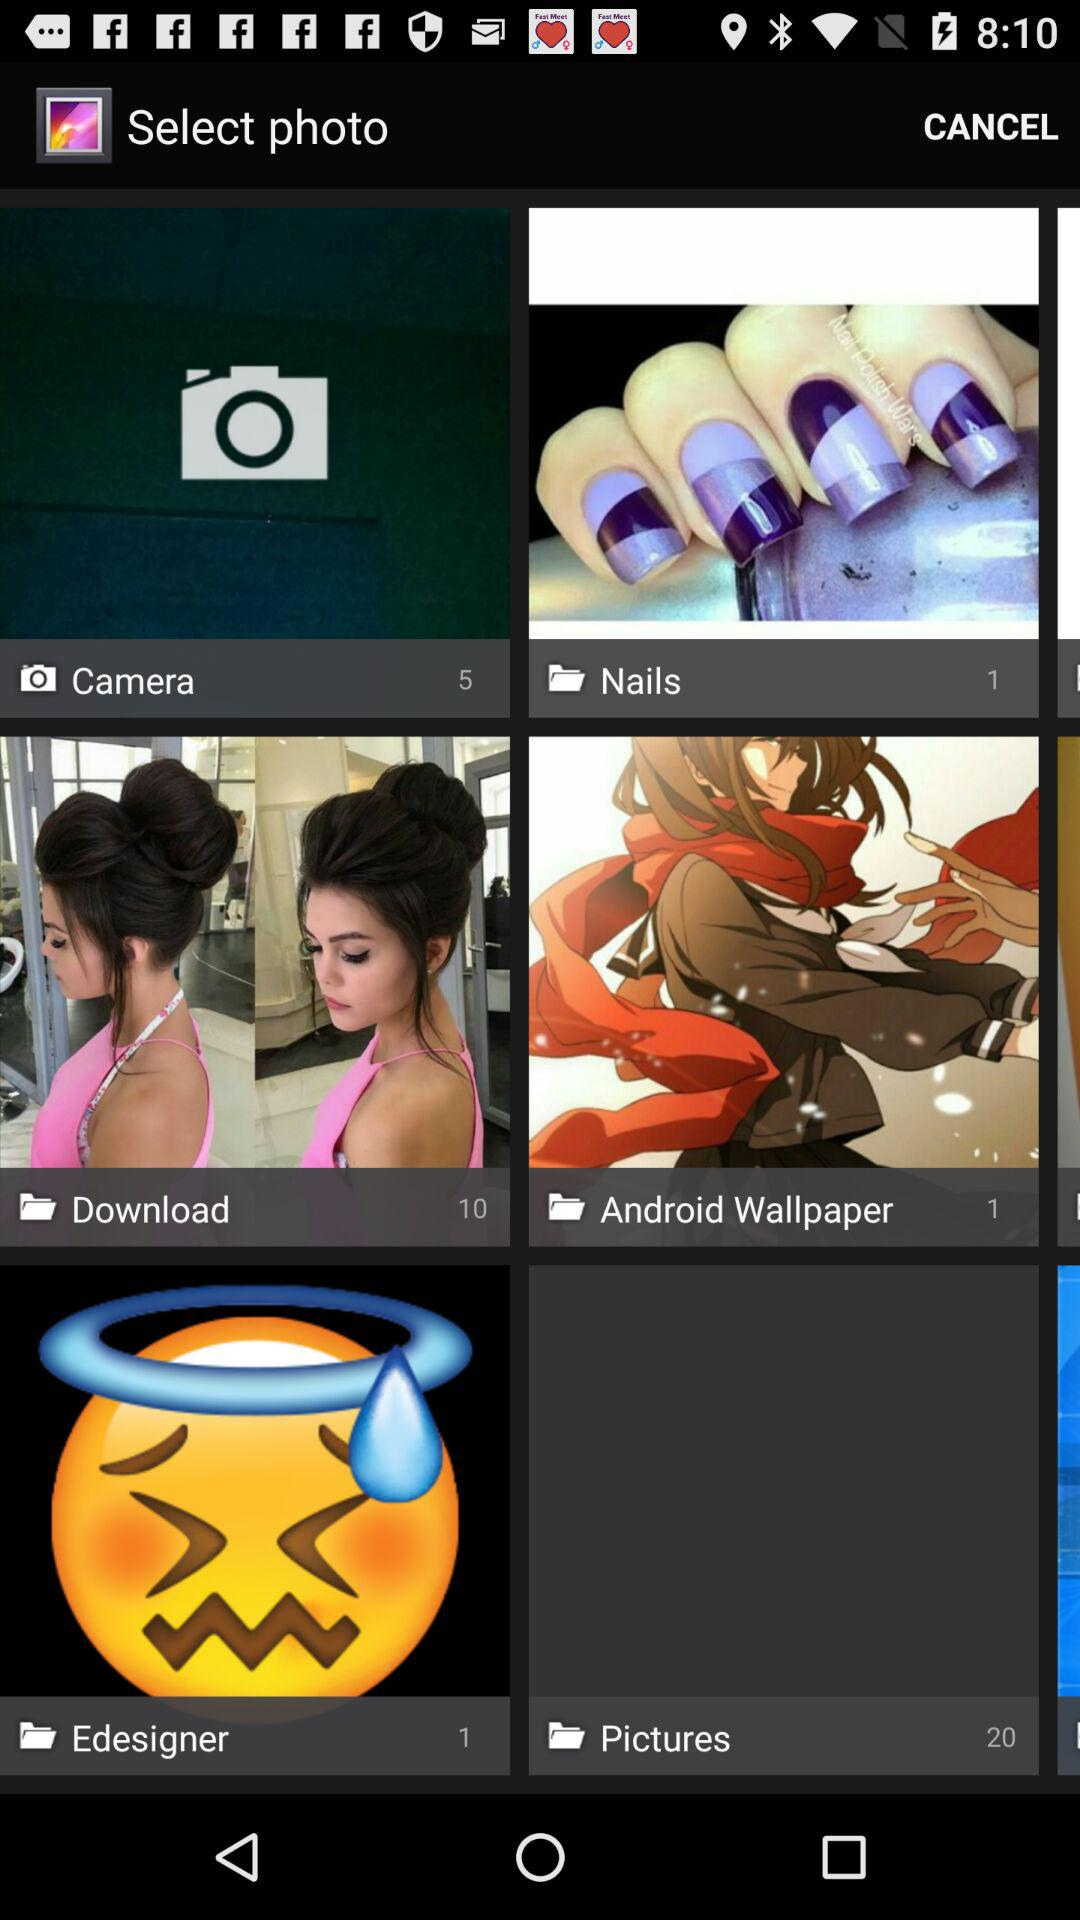What is the number of images in the "Pictures" folder? The number of images is 20. 